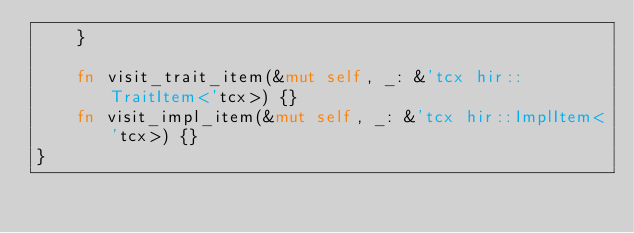Convert code to text. <code><loc_0><loc_0><loc_500><loc_500><_Rust_>    }

    fn visit_trait_item(&mut self, _: &'tcx hir::TraitItem<'tcx>) {}
    fn visit_impl_item(&mut self, _: &'tcx hir::ImplItem<'tcx>) {}
}
</code> 